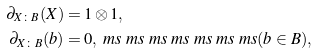<formula> <loc_0><loc_0><loc_500><loc_500>\partial _ { X \colon B } ( X ) & = 1 \otimes 1 , \\ \partial _ { X \colon B } ( b ) & = 0 , \ m s \ m s \ m s \ m s \ m s \ m s \ m s ( b \in B ) ,</formula> 